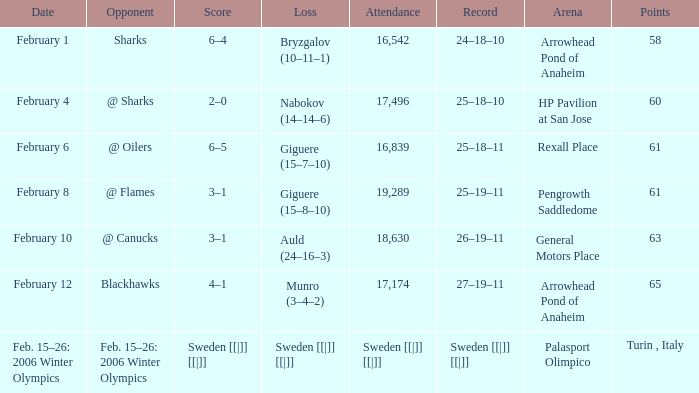What is the milestone at palasport olimpico? Sweden [[|]] [[|]]. 